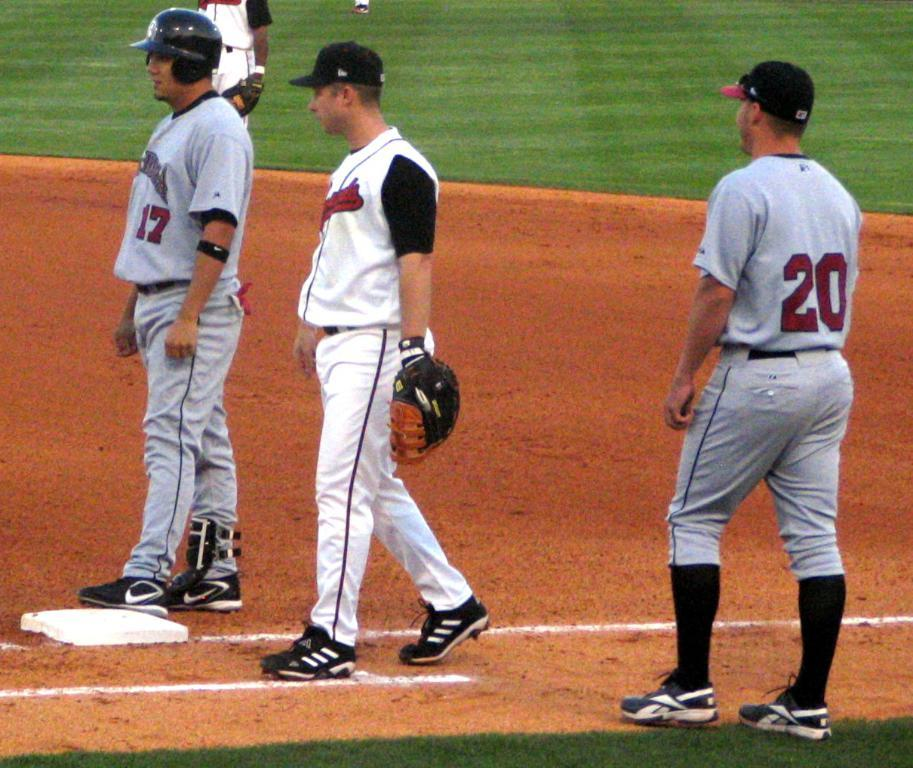Provide a one-sentence caption for the provided image. number 17 and number 20 are from the team with gray jersey. 